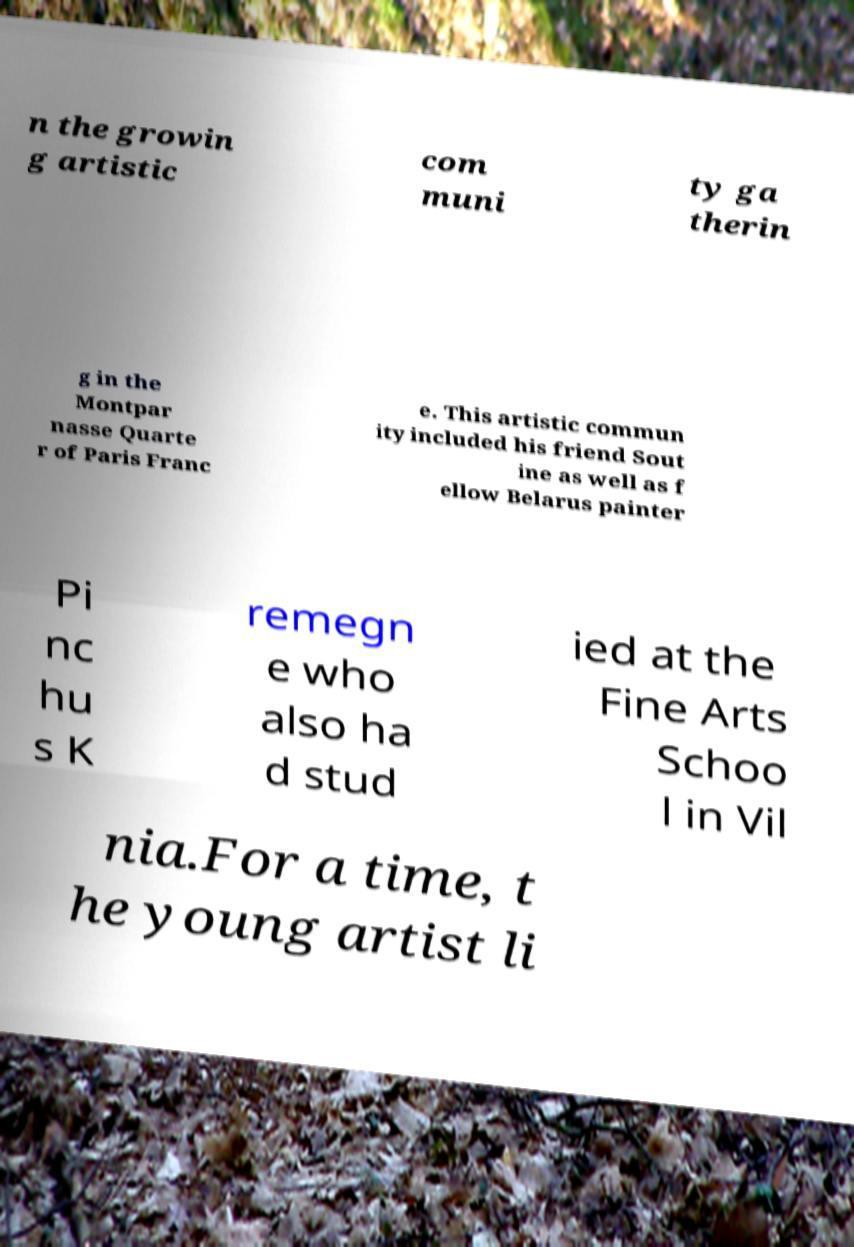Can you accurately transcribe the text from the provided image for me? n the growin g artistic com muni ty ga therin g in the Montpar nasse Quarte r of Paris Franc e. This artistic commun ity included his friend Sout ine as well as f ellow Belarus painter Pi nc hu s K remegn e who also ha d stud ied at the Fine Arts Schoo l in Vil nia.For a time, t he young artist li 